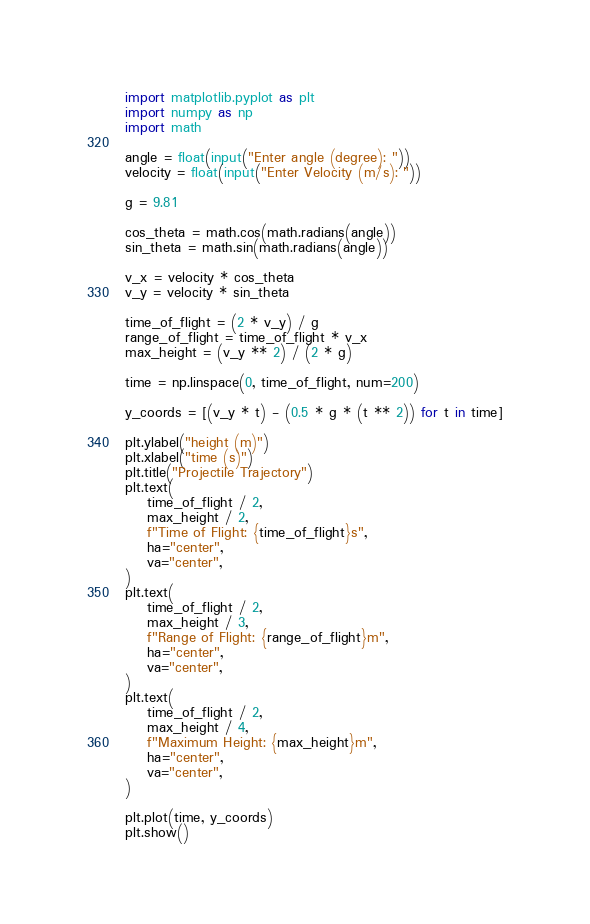<code> <loc_0><loc_0><loc_500><loc_500><_Python_>import matplotlib.pyplot as plt
import numpy as np
import math

angle = float(input("Enter angle (degree): "))
velocity = float(input("Enter Velocity (m/s): "))

g = 9.81

cos_theta = math.cos(math.radians(angle))
sin_theta = math.sin(math.radians(angle))

v_x = velocity * cos_theta
v_y = velocity * sin_theta

time_of_flight = (2 * v_y) / g
range_of_flight = time_of_flight * v_x
max_height = (v_y ** 2) / (2 * g)

time = np.linspace(0, time_of_flight, num=200)

y_coords = [(v_y * t) - (0.5 * g * (t ** 2)) for t in time]

plt.ylabel("height (m)")
plt.xlabel("time (s)")
plt.title("Projectile Trajectory")
plt.text(
    time_of_flight / 2,
    max_height / 2,
    f"Time of Flight: {time_of_flight}s",
    ha="center",
    va="center",
)
plt.text(
    time_of_flight / 2,
    max_height / 3,
    f"Range of Flight: {range_of_flight}m",
    ha="center",
    va="center",
)
plt.text(
    time_of_flight / 2,
    max_height / 4,
    f"Maximum Height: {max_height}m",
    ha="center",
    va="center",
)

plt.plot(time, y_coords)
plt.show()
</code> 